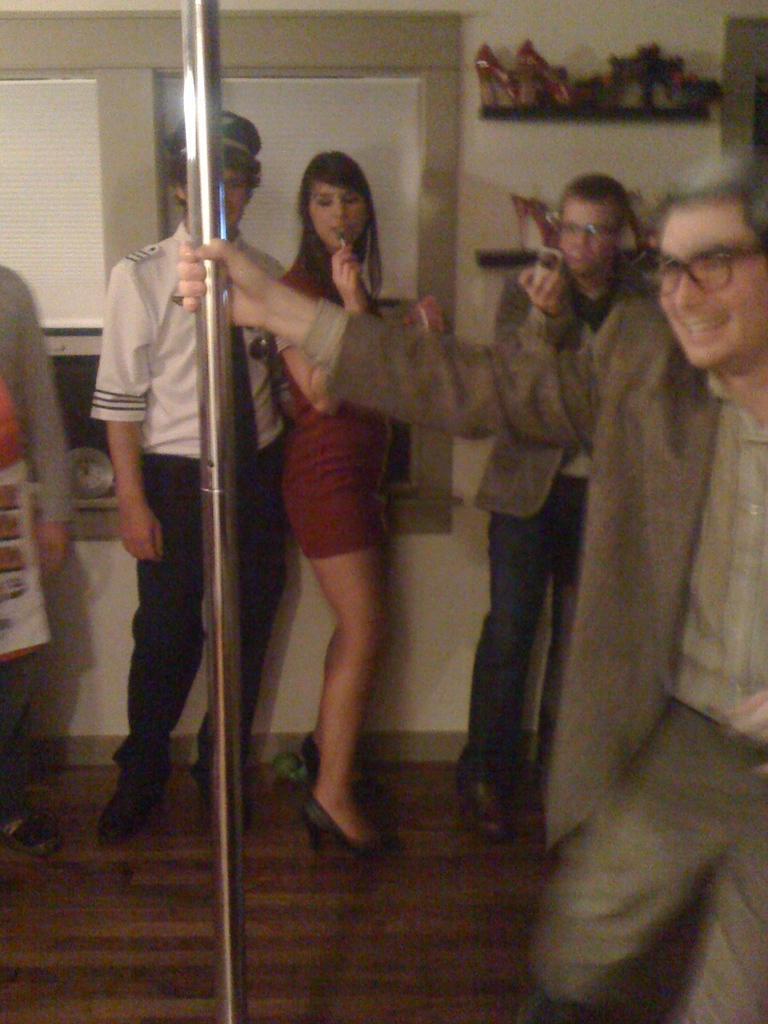In one or two sentences, can you explain what this image depicts? This is the picture of a room. On the right side of the image there is a person standing and smiling and he is holding the rod. At the back there are group of people standing. There are windows and there are objects on the cupboard. At the back there's a wall. At the bottom there is a wooden floor. 